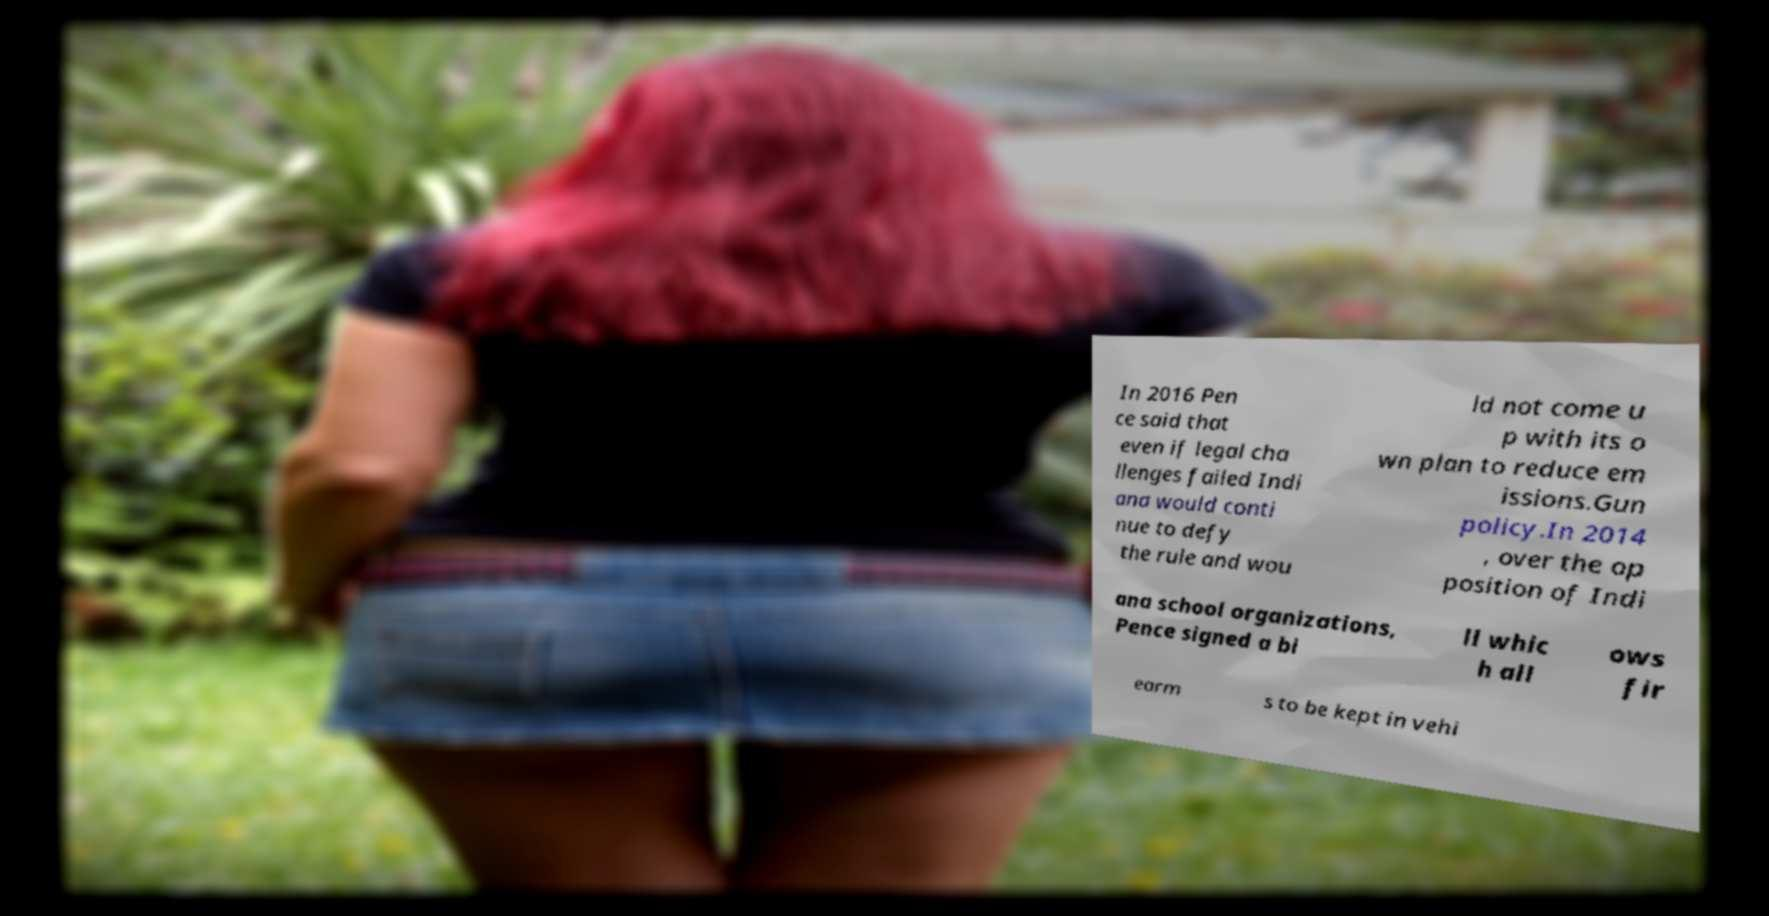Please identify and transcribe the text found in this image. In 2016 Pen ce said that even if legal cha llenges failed Indi ana would conti nue to defy the rule and wou ld not come u p with its o wn plan to reduce em issions.Gun policy.In 2014 , over the op position of Indi ana school organizations, Pence signed a bi ll whic h all ows fir earm s to be kept in vehi 